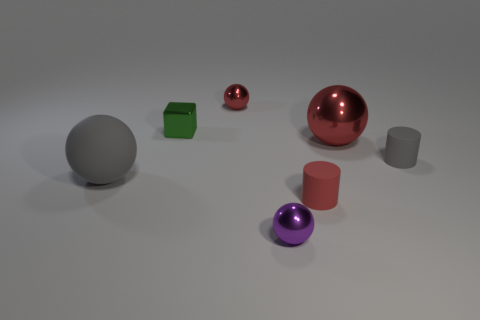Subtract all big gray balls. How many balls are left? 3 Add 1 small cyan rubber things. How many objects exist? 8 Subtract all gray cylinders. How many cylinders are left? 1 Subtract all blocks. How many objects are left? 6 Subtract 3 balls. How many balls are left? 1 Subtract all green balls. Subtract all yellow cylinders. How many balls are left? 4 Subtract all cyan spheres. How many red cylinders are left? 1 Subtract all small purple balls. Subtract all green blocks. How many objects are left? 5 Add 2 cubes. How many cubes are left? 3 Add 1 tiny red metallic things. How many tiny red metallic things exist? 2 